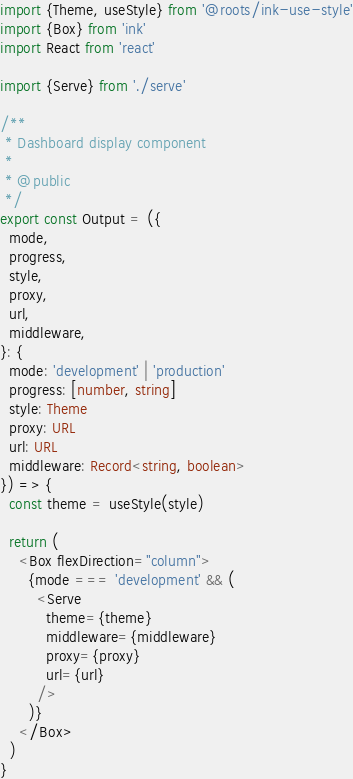<code> <loc_0><loc_0><loc_500><loc_500><_TypeScript_>import {Theme, useStyle} from '@roots/ink-use-style'
import {Box} from 'ink'
import React from 'react'

import {Serve} from './serve'

/**
 * Dashboard display component
 *
 * @public
 */
export const Output = ({
  mode,
  progress,
  style,
  proxy,
  url,
  middleware,
}: {
  mode: 'development' | 'production'
  progress: [number, string]
  style: Theme
  proxy: URL
  url: URL
  middleware: Record<string, boolean>
}) => {
  const theme = useStyle(style)

  return (
    <Box flexDirection="column">
      {mode === 'development' && (
        <Serve
          theme={theme}
          middleware={middleware}
          proxy={proxy}
          url={url}
        />
      )}
    </Box>
  )
}
</code> 